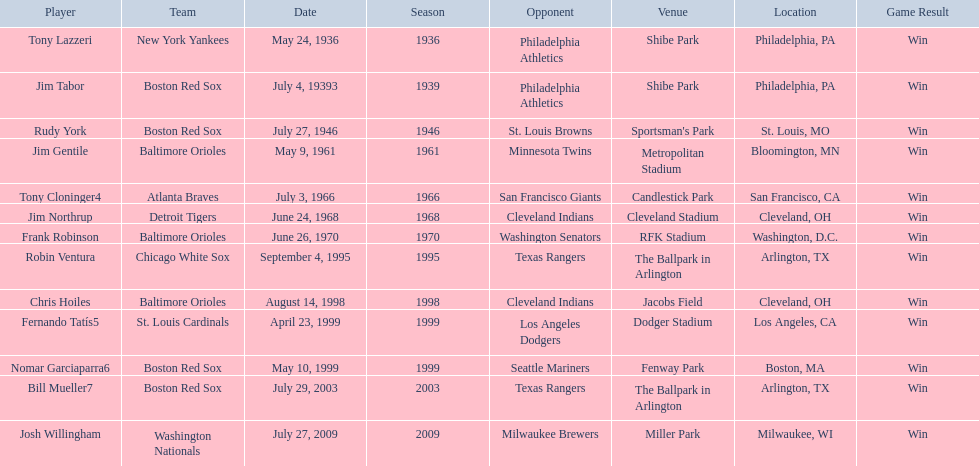Who are the opponents of the boston red sox during baseball home run records? Philadelphia Athletics, St. Louis Browns, Seattle Mariners, Texas Rangers. Of those which was the opponent on july 27, 1946? St. Louis Browns. 